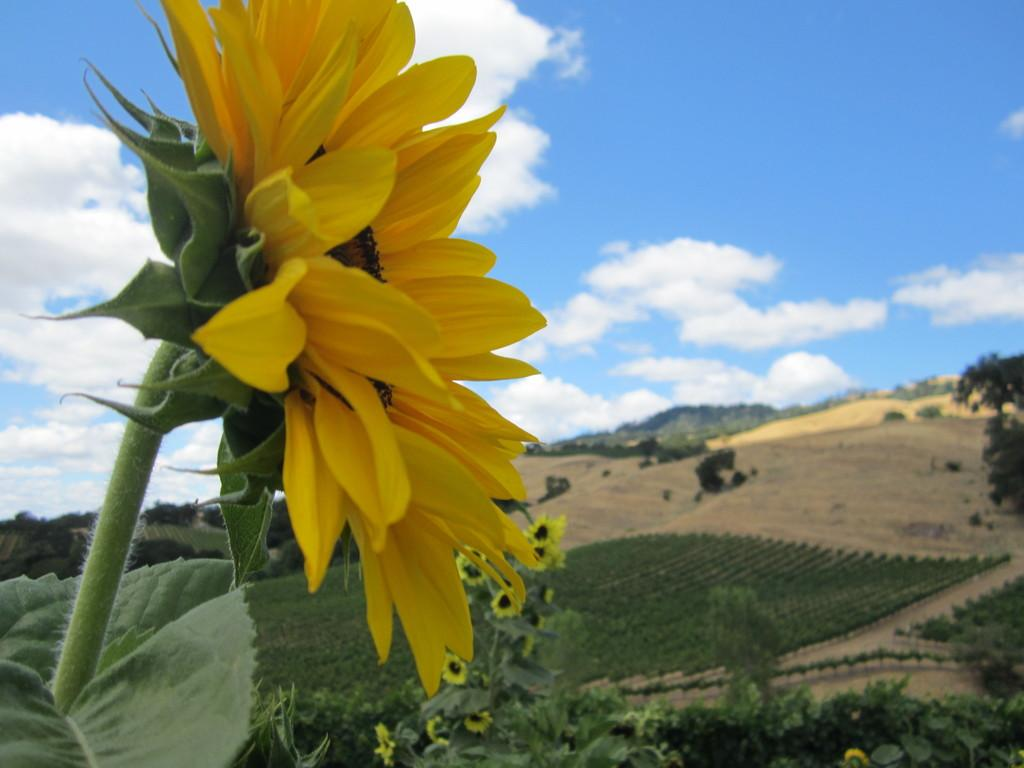What type of vegetation can be seen in the image? There are trees, flowers, and plants in the image. What is the color and condition of the sky in the image? The sky is blue and cloudy in the image. Can you tell me what the kitty is writing on the expert's desk in the image? There is no kitty or desk present in the image; it features trees, flowers, plants, and a blue, cloudy sky. 